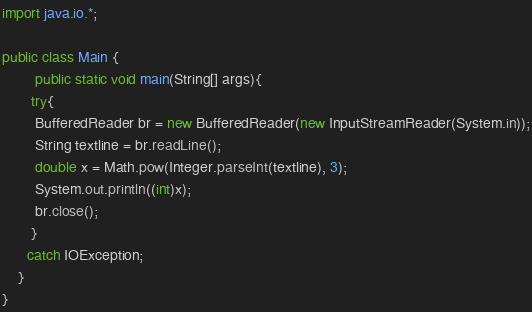<code> <loc_0><loc_0><loc_500><loc_500><_Java_>import java.io.*;
 
public class Main {
        public static void main(String[] args){
       try{
        BufferedReader br = new BufferedReader(new InputStreamReader(System.in));
        String textline = br.readLine();
        double x = Math.pow(Integer.parseInt(textline), 3);
        System.out.println((int)x);
        br.close();
       }
      catch IOException;
    }
}</code> 